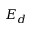Convert formula to latex. <formula><loc_0><loc_0><loc_500><loc_500>E _ { d }</formula> 